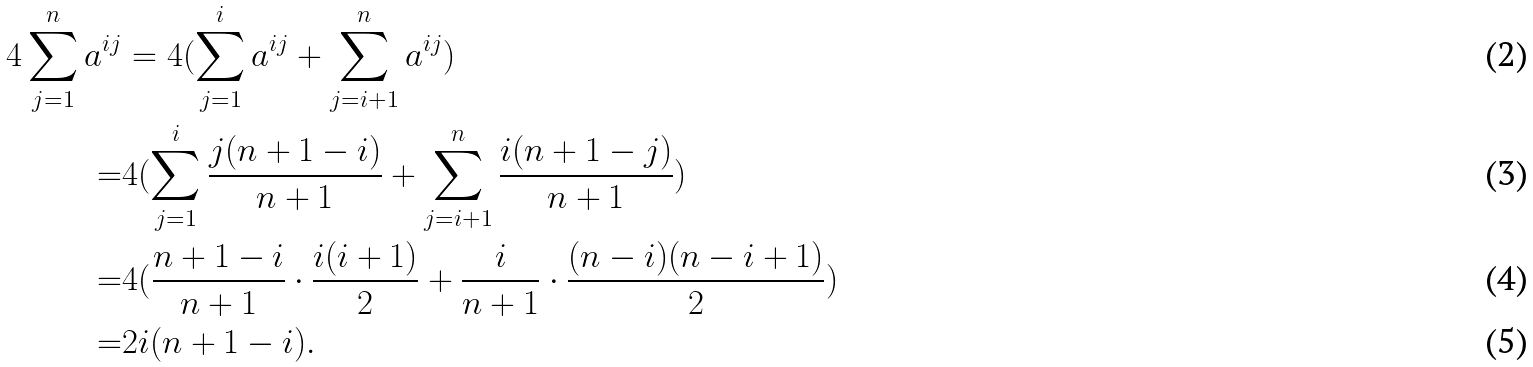Convert formula to latex. <formula><loc_0><loc_0><loc_500><loc_500>4 \sum _ { j = 1 } ^ { n } a ^ { i j } & = 4 ( \sum _ { j = 1 } ^ { i } a ^ { i j } + \sum _ { j = i + 1 } ^ { n } a ^ { i j } ) \\ = & 4 ( \sum _ { j = 1 } ^ { i } \frac { j ( n + 1 - i ) } { n + 1 } + \sum _ { j = i + 1 } ^ { n } \frac { i ( n + 1 - j ) } { n + 1 } ) \\ = & 4 ( \frac { n + 1 - i } { n + 1 } \cdot \frac { i ( i + 1 ) } 2 + \frac { i } { n + 1 } \cdot \frac { ( n - i ) ( n - i + 1 ) } 2 ) \\ = & 2 i ( n + 1 - i ) .</formula> 